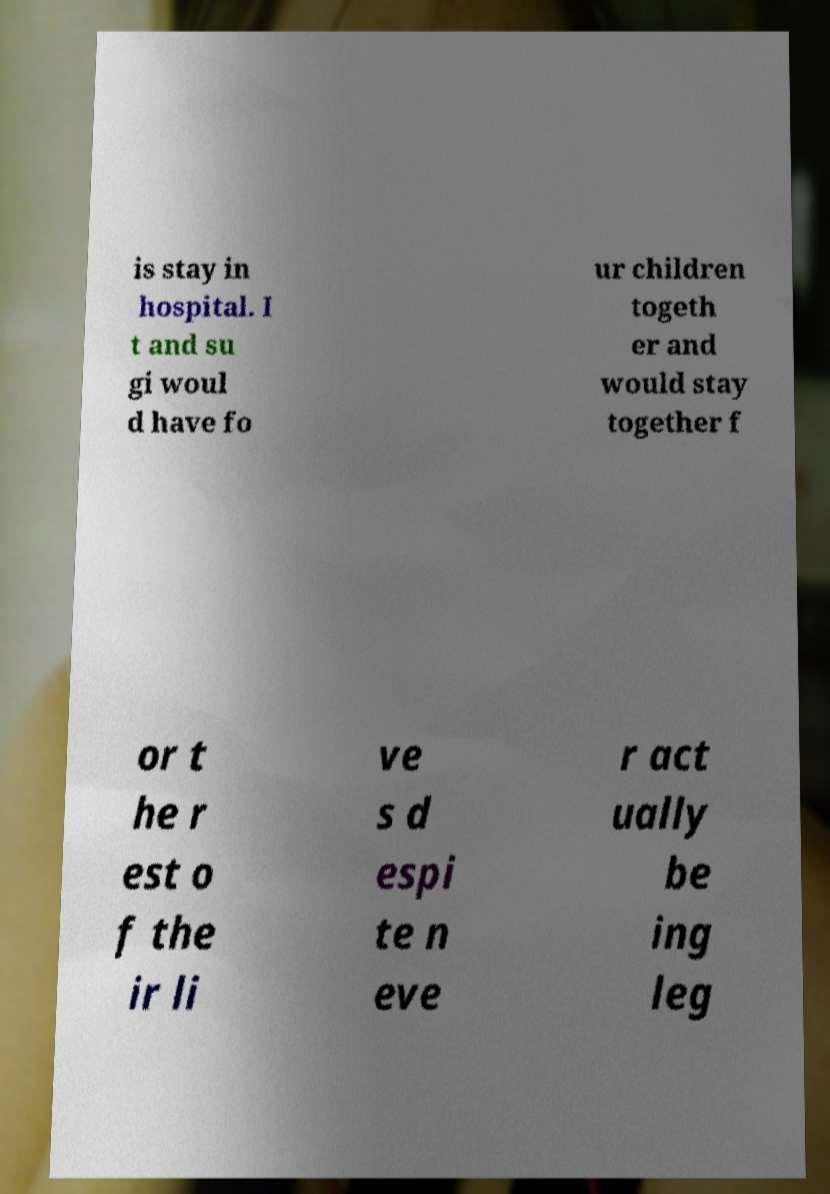There's text embedded in this image that I need extracted. Can you transcribe it verbatim? is stay in hospital. I t and su gi woul d have fo ur children togeth er and would stay together f or t he r est o f the ir li ve s d espi te n eve r act ually be ing leg 